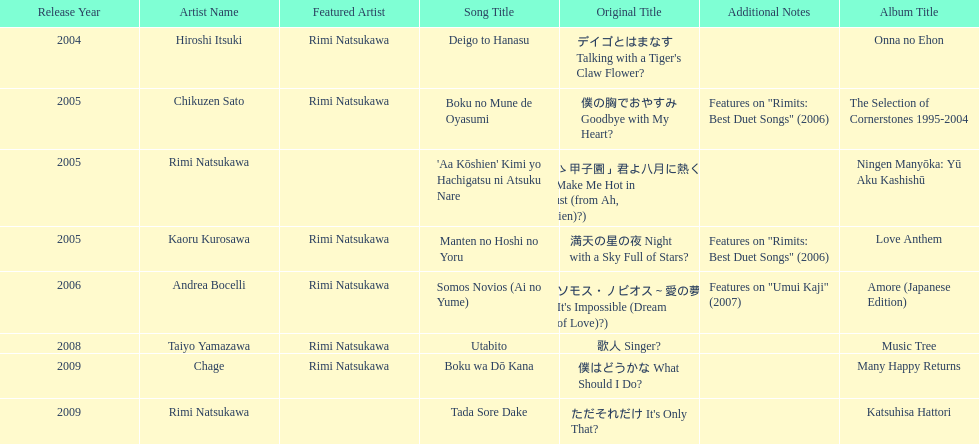What is the number of albums released with the artist rimi natsukawa? 8. I'm looking to parse the entire table for insights. Could you assist me with that? {'header': ['Release Year', 'Artist Name', 'Featured Artist', 'Song Title', 'Original Title', 'Additional Notes', 'Album Title'], 'rows': [['2004', 'Hiroshi Itsuki', 'Rimi Natsukawa', 'Deigo to Hanasu', "デイゴとはまなす Talking with a Tiger's Claw Flower?", '', 'Onna no Ehon'], ['2005', 'Chikuzen Sato', 'Rimi Natsukawa', 'Boku no Mune de Oyasumi', '僕の胸でおやすみ Goodbye with My Heart?', 'Features on "Rimits: Best Duet Songs" (2006)', 'The Selection of Cornerstones 1995-2004'], ['2005', 'Rimi Natsukawa', '', "'Aa Kōshien' Kimi yo Hachigatsu ni Atsuku Nare", '「あゝ甲子園」君よ八月に熱くなれ You Make Me Hot in August (from Ah, Kōshien)?)', '', 'Ningen Manyōka: Yū Aku Kashishū'], ['2005', 'Kaoru Kurosawa', 'Rimi Natsukawa', 'Manten no Hoshi no Yoru', '満天の星の夜 Night with a Sky Full of Stars?', 'Features on "Rimits: Best Duet Songs" (2006)', 'Love Anthem'], ['2006', 'Andrea Bocelli', 'Rimi Natsukawa', 'Somos Novios (Ai no Yume)', "ソモス・ノビオス～愛の夢 It's Impossible (Dream of Love)?)", 'Features on "Umui Kaji" (2007)', 'Amore (Japanese Edition)'], ['2008', 'Taiyo Yamazawa', 'Rimi Natsukawa', 'Utabito', '歌人 Singer?', '', 'Music Tree'], ['2009', 'Chage', 'Rimi Natsukawa', 'Boku wa Dō Kana', '僕はどうかな What Should I Do?', '', 'Many Happy Returns'], ['2009', 'Rimi Natsukawa', '', 'Tada Sore Dake', "ただそれだけ It's Only That?", '', 'Katsuhisa Hattori']]} 